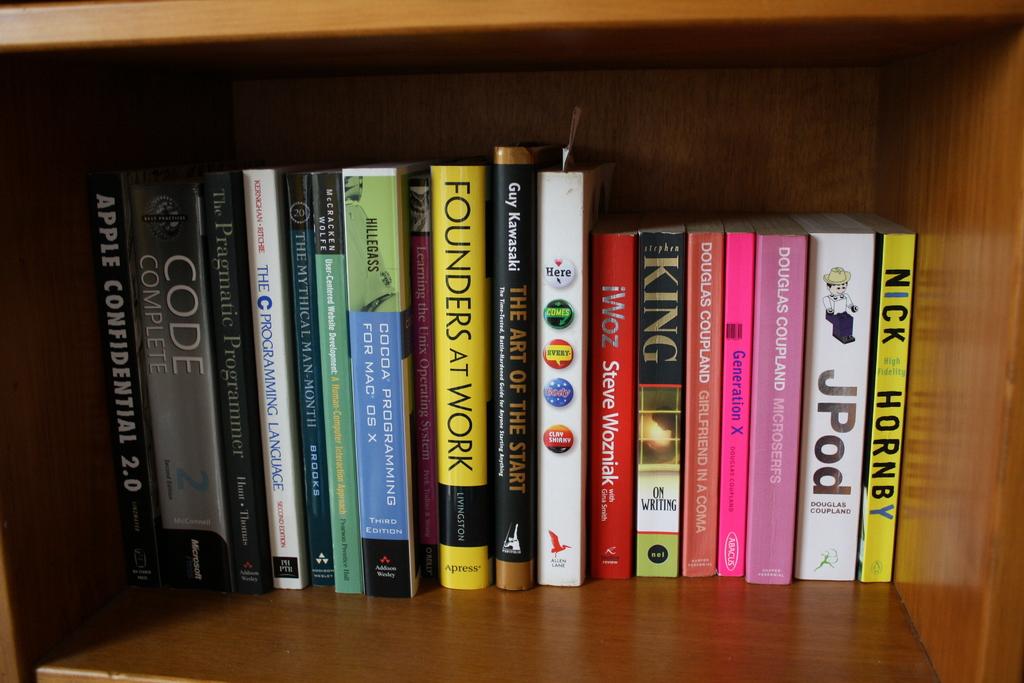What is the book title on the far right?
Your answer should be very brief. High fidelity. Who is at work according to the middle yellow book?
Offer a very short reply. Founders. 